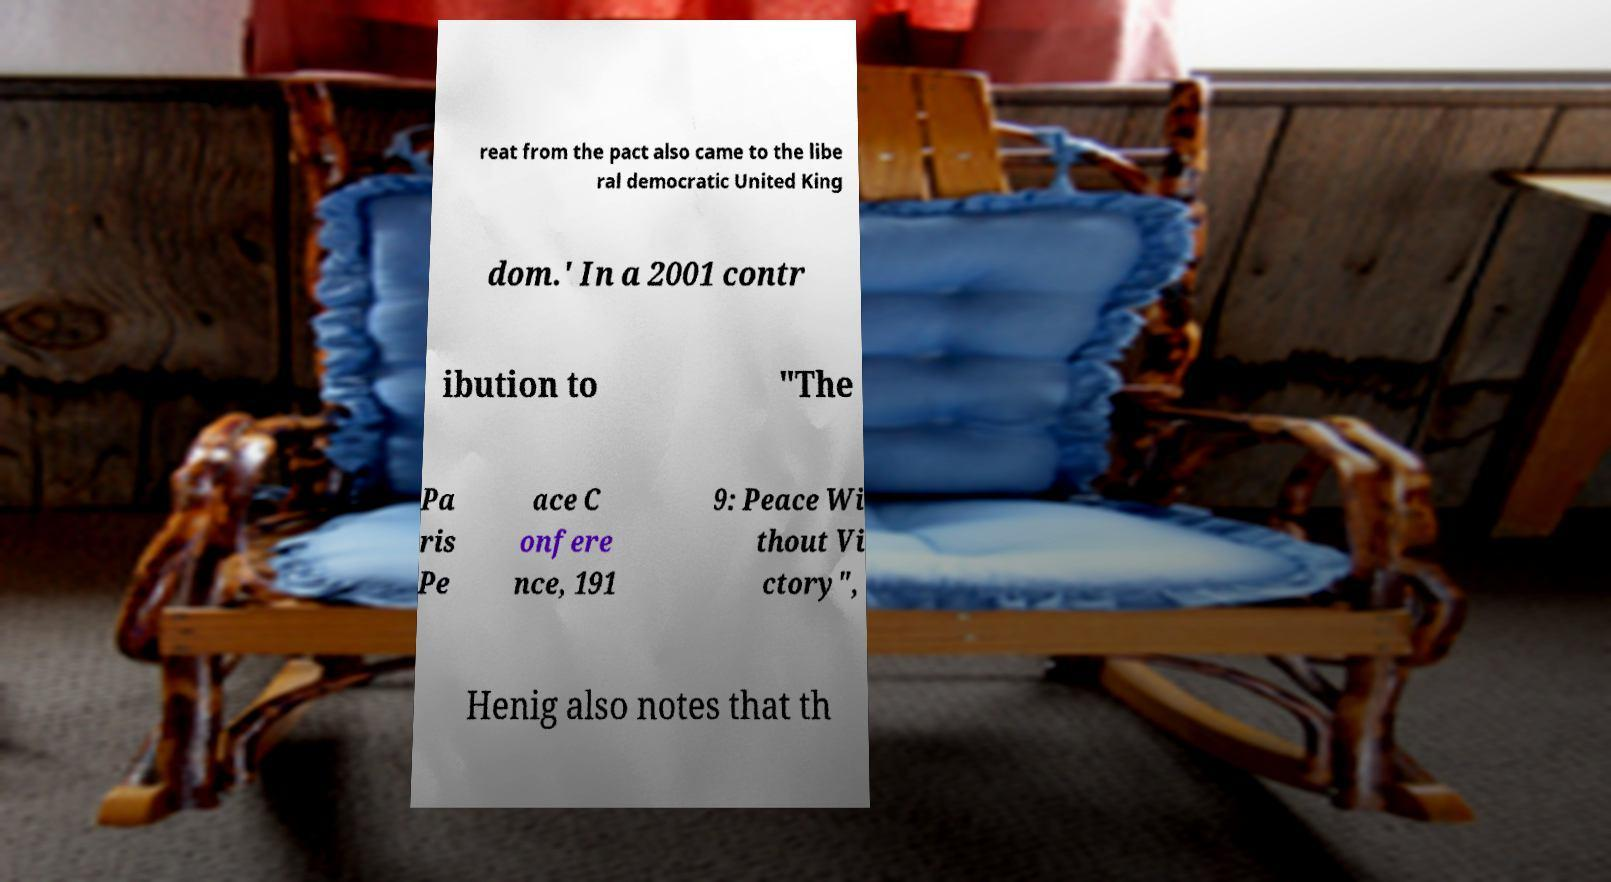There's text embedded in this image that I need extracted. Can you transcribe it verbatim? reat from the pact also came to the libe ral democratic United King dom.' In a 2001 contr ibution to "The Pa ris Pe ace C onfere nce, 191 9: Peace Wi thout Vi ctory", Henig also notes that th 